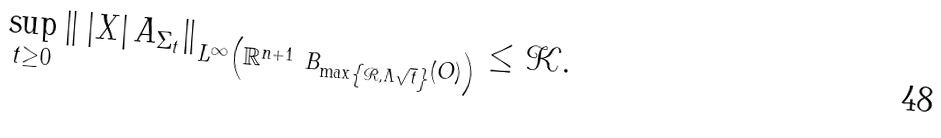Convert formula to latex. <formula><loc_0><loc_0><loc_500><loc_500>\sup _ { t \geq 0 } \left \| \, \left | X \right | A _ { \Sigma _ { t } } \right \| _ { L ^ { \infty } \left ( \mathbb { R } ^ { n + 1 } \ B _ { \max \left \{ \mathcal { R } , \Lambda \sqrt { t } \right \} } \left ( O \right ) \right ) } \leq \mathcal { K } .</formula> 